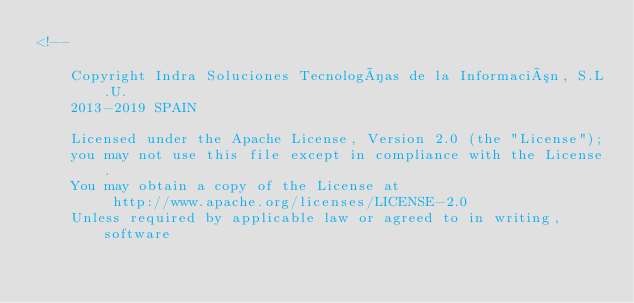<code> <loc_0><loc_0><loc_500><loc_500><_HTML_><!--

    Copyright Indra Soluciones Tecnologías de la Información, S.L.U.
    2013-2019 SPAIN

    Licensed under the Apache License, Version 2.0 (the "License");
    you may not use this file except in compliance with the License.
    You may obtain a copy of the License at
         http://www.apache.org/licenses/LICENSE-2.0
    Unless required by applicable law or agreed to in writing, software</code> 